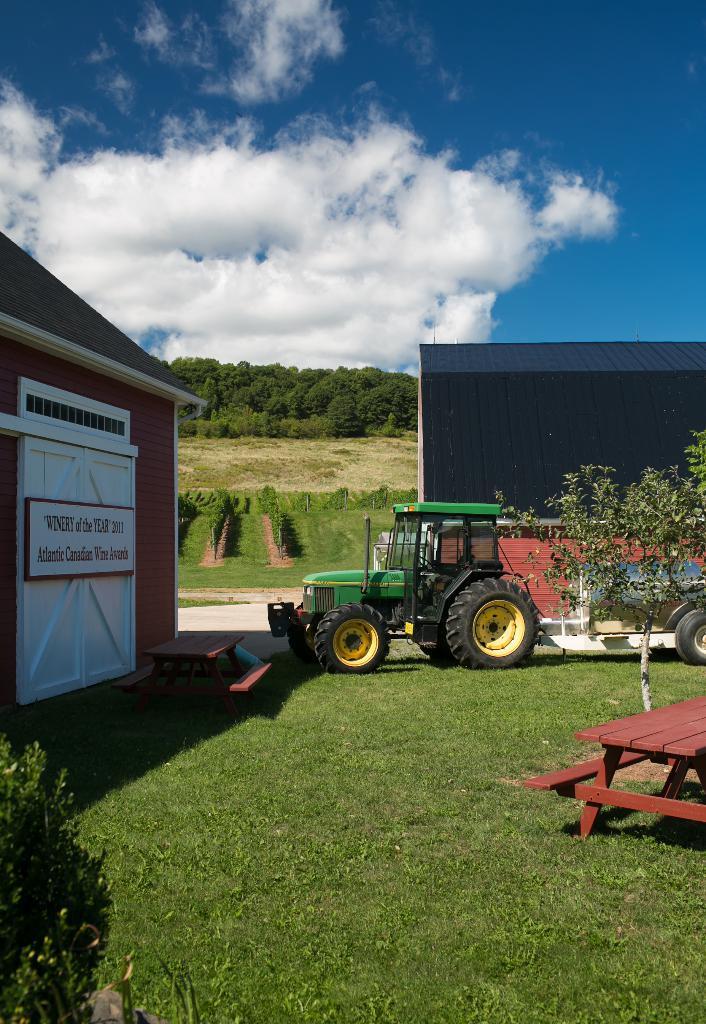Please provide a concise description of this image. There is a vehicle on the grass. This is plant. Here we can see some trees. There is a house. On the background there is a sky with heavy clouds. 